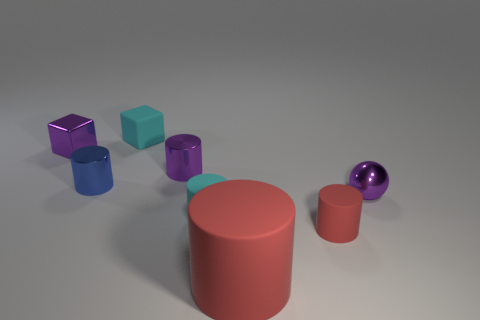Subtract 1 cylinders. How many cylinders are left? 4 Subtract all green cylinders. Subtract all green blocks. How many cylinders are left? 5 Add 1 tiny red matte cylinders. How many objects exist? 9 Subtract all cubes. How many objects are left? 6 Add 7 small purple blocks. How many small purple blocks exist? 8 Subtract 0 yellow balls. How many objects are left? 8 Subtract all small purple metallic cylinders. Subtract all red rubber objects. How many objects are left? 5 Add 5 tiny cyan rubber cylinders. How many tiny cyan rubber cylinders are left? 6 